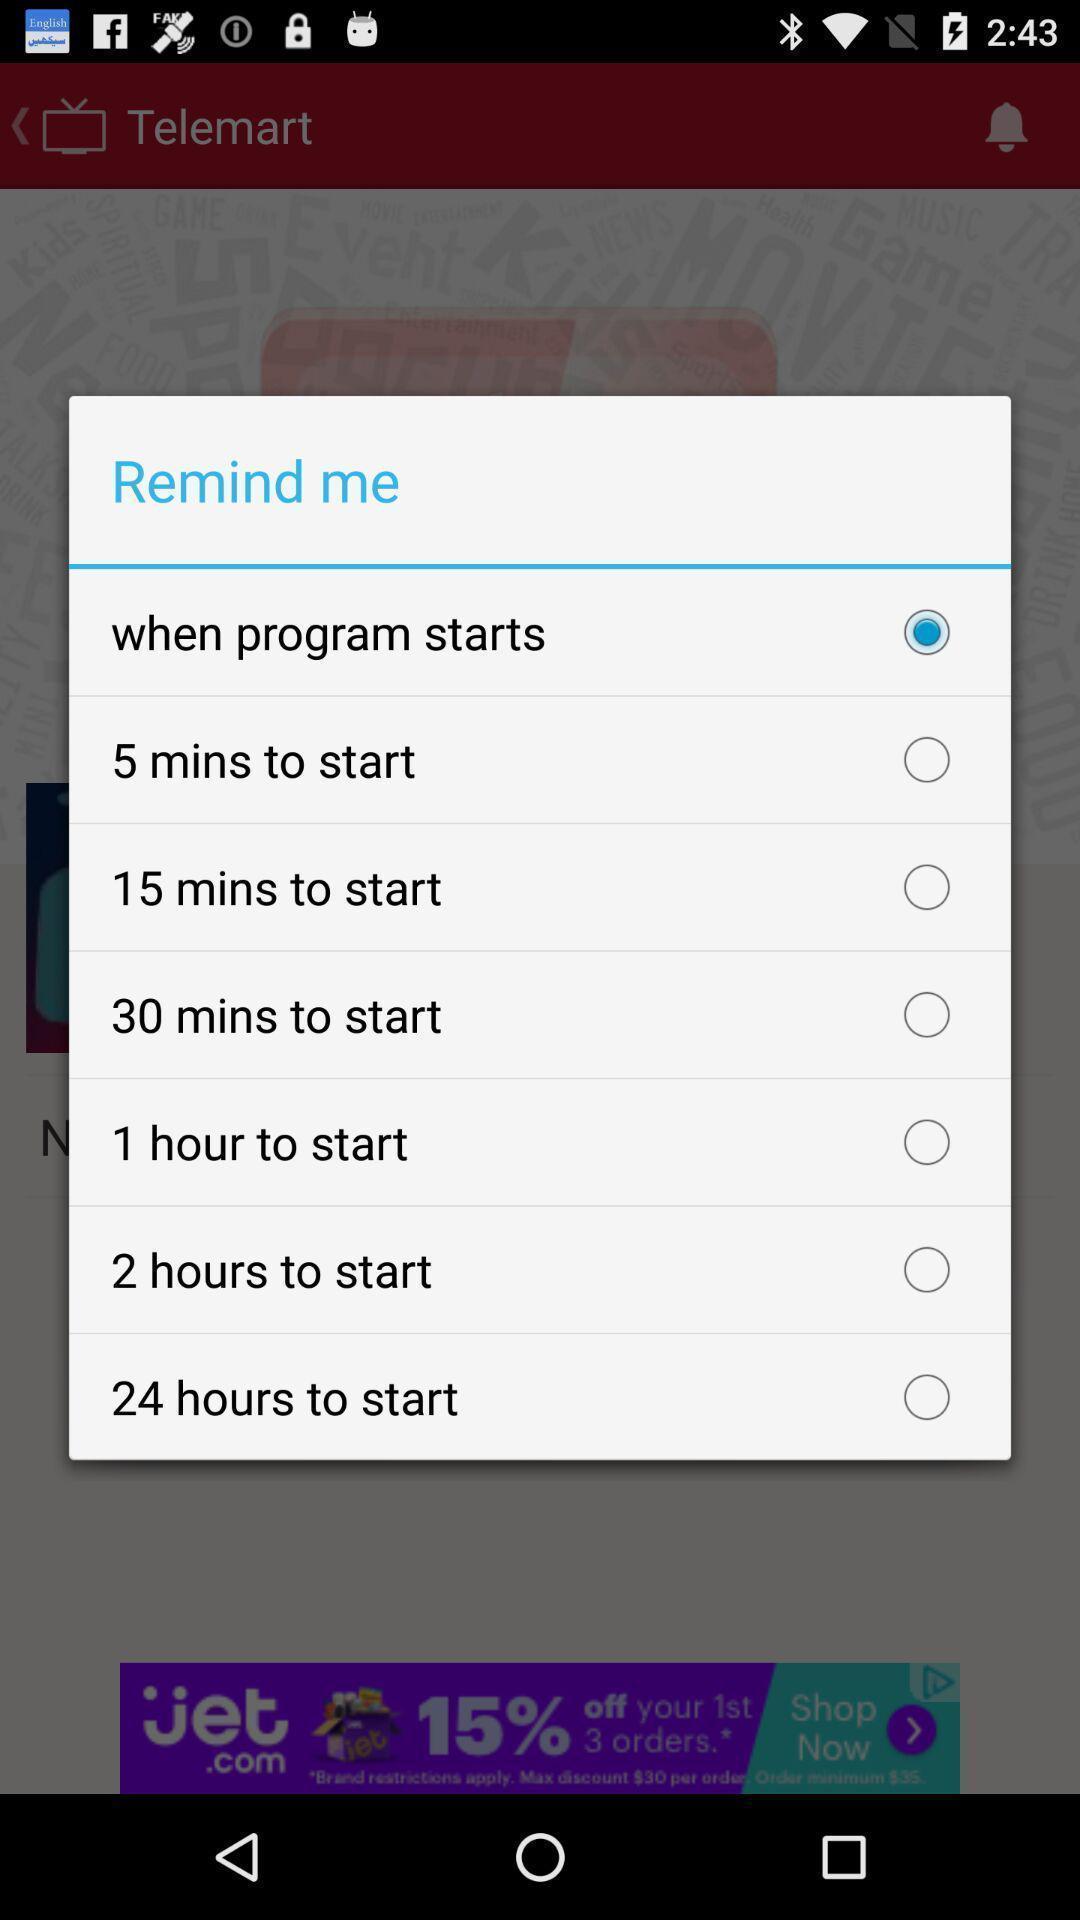Summarize the main components in this picture. Setting time duration for pop up alerts. 